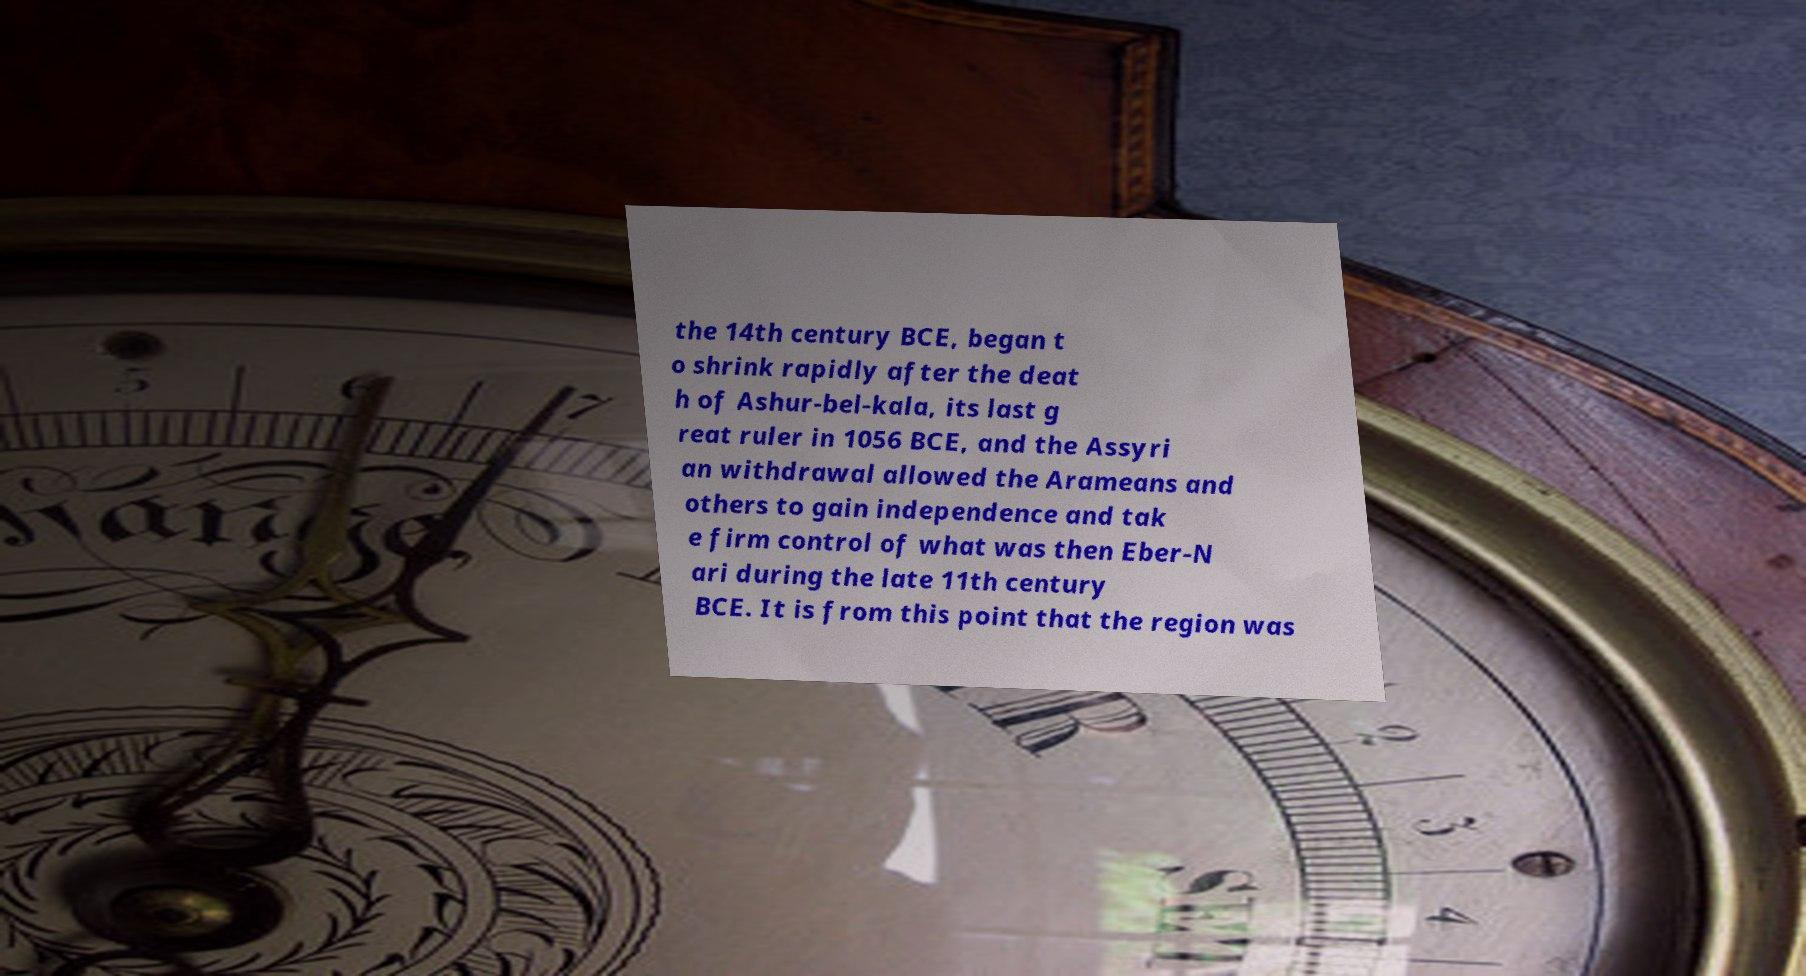Can you accurately transcribe the text from the provided image for me? the 14th century BCE, began t o shrink rapidly after the deat h of Ashur-bel-kala, its last g reat ruler in 1056 BCE, and the Assyri an withdrawal allowed the Arameans and others to gain independence and tak e firm control of what was then Eber-N ari during the late 11th century BCE. It is from this point that the region was 